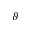Convert formula to latex. <formula><loc_0><loc_0><loc_500><loc_500>\vartheta</formula> 